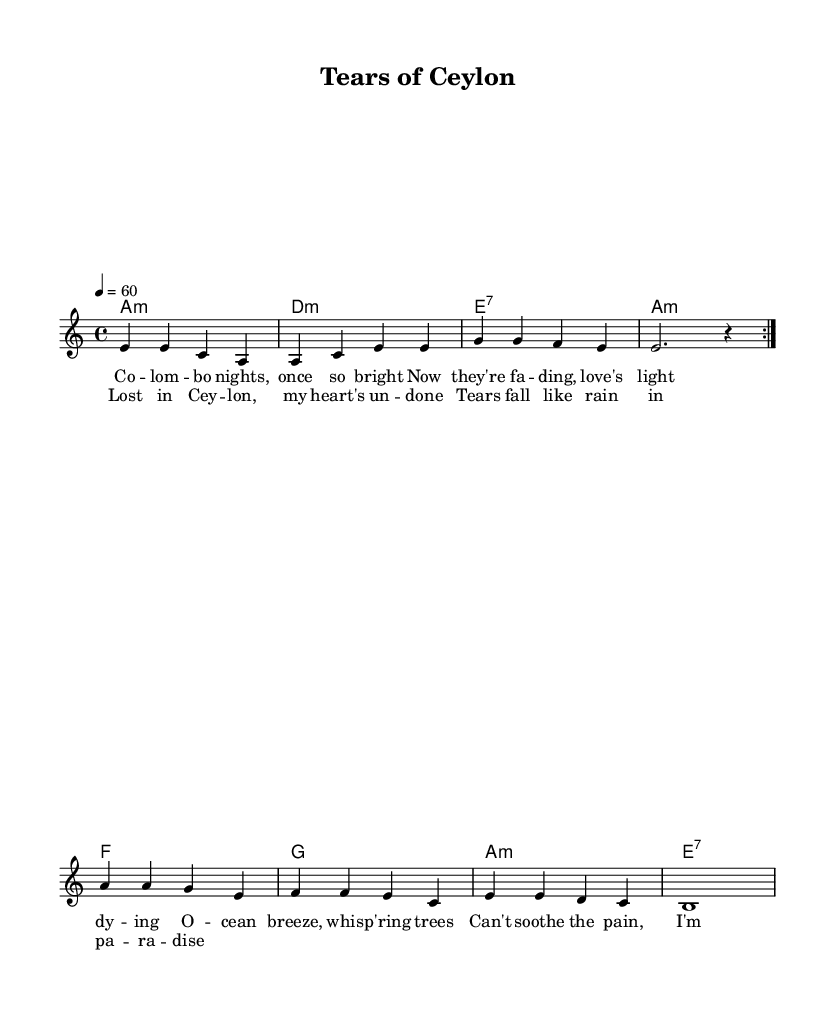What is the key signature of this music? The key signature is indicated as 'a minor', meaning it has no sharps or flats. The key signature is usually shown at the beginning of the staff.
Answer: a minor What is the time signature of the music? The time signature is shown at the beginning and indicates how many beats are in each measure. In this case, it is '4/4', which means there are four beats per measure.
Answer: 4/4 What is the tempo marking of this piece? The tempo marking, indicated in beats per minute, is '60'. This tells the performer to play at a moderate speed of one beat per second.
Answer: 60 How many measures are there in the repeat section? The repeat section within the 'melody' is indicated by the 'volta' markings and consists of two identical sections. Counting each line, there are 4 measures per repeat. Thus, the section has 8 measures total.
Answer: 8 What is the emotional theme expressed in the lyrics? The lyrics convey a sense of heartbreak and loss, expressing sorrow about fading love and emotional pain while mentioning specific imagery like "Colombo nights" and "ocean breeze". This aligns with the common themes found in blues music.
Answer: heartbreak and loss Which chord is played after the 'chorus'? The last chord indicated after the 'chorus' section is 'e:7', commonly used in blues to express a feeling of resolution while still maintaining emotional tension.
Answer: e:7 